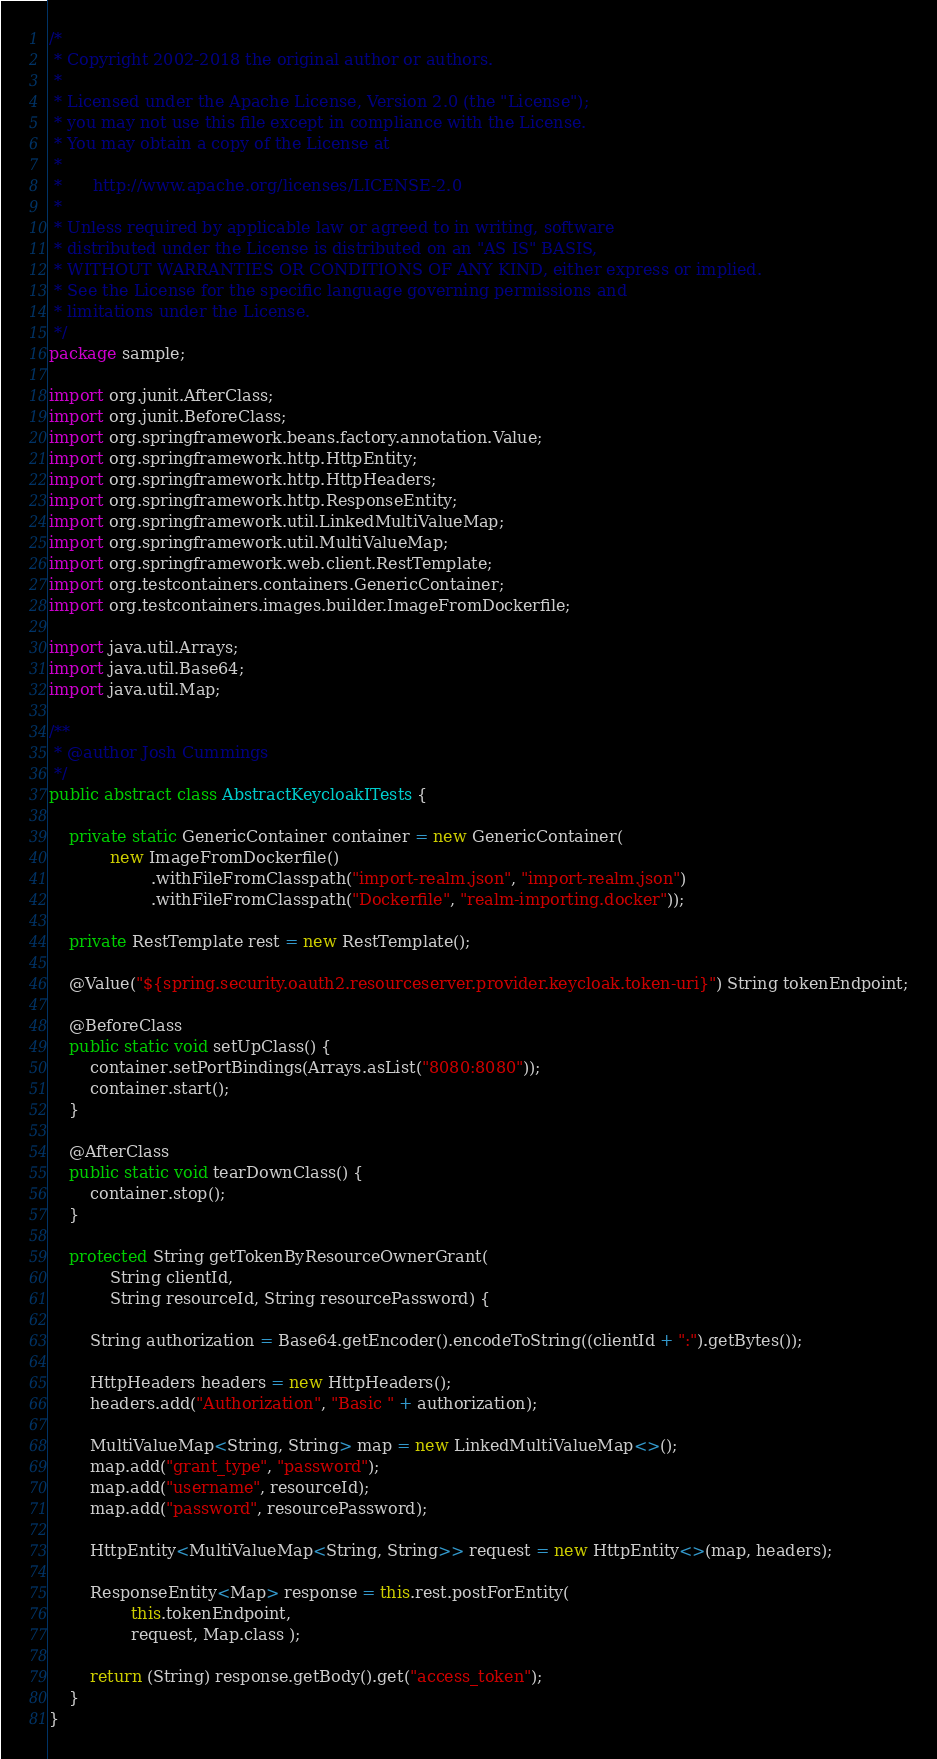Convert code to text. <code><loc_0><loc_0><loc_500><loc_500><_Java_>/*
 * Copyright 2002-2018 the original author or authors.
 *
 * Licensed under the Apache License, Version 2.0 (the "License");
 * you may not use this file except in compliance with the License.
 * You may obtain a copy of the License at
 *
 *      http://www.apache.org/licenses/LICENSE-2.0
 *
 * Unless required by applicable law or agreed to in writing, software
 * distributed under the License is distributed on an "AS IS" BASIS,
 * WITHOUT WARRANTIES OR CONDITIONS OF ANY KIND, either express or implied.
 * See the License for the specific language governing permissions and
 * limitations under the License.
 */
package sample;

import org.junit.AfterClass;
import org.junit.BeforeClass;
import org.springframework.beans.factory.annotation.Value;
import org.springframework.http.HttpEntity;
import org.springframework.http.HttpHeaders;
import org.springframework.http.ResponseEntity;
import org.springframework.util.LinkedMultiValueMap;
import org.springframework.util.MultiValueMap;
import org.springframework.web.client.RestTemplate;
import org.testcontainers.containers.GenericContainer;
import org.testcontainers.images.builder.ImageFromDockerfile;

import java.util.Arrays;
import java.util.Base64;
import java.util.Map;

/**
 * @author Josh Cummings
 */
public abstract class AbstractKeycloakITests {

	private static GenericContainer container = new GenericContainer(
			new ImageFromDockerfile()
					.withFileFromClasspath("import-realm.json", "import-realm.json")
					.withFileFromClasspath("Dockerfile", "realm-importing.docker"));

	private RestTemplate rest = new RestTemplate();

	@Value("${spring.security.oauth2.resourceserver.provider.keycloak.token-uri}") String tokenEndpoint;

	@BeforeClass
	public static void setUpClass() {
		container.setPortBindings(Arrays.asList("8080:8080"));
		container.start();
	}

	@AfterClass
	public static void tearDownClass() {
		container.stop();
	}

	protected String getTokenByResourceOwnerGrant(
			String clientId,
			String resourceId, String resourcePassword) {

		String authorization = Base64.getEncoder().encodeToString((clientId + ":").getBytes());

		HttpHeaders headers = new HttpHeaders();
		headers.add("Authorization", "Basic " + authorization);

		MultiValueMap<String, String> map = new LinkedMultiValueMap<>();
		map.add("grant_type", "password");
		map.add("username", resourceId);
		map.add("password", resourcePassword);

		HttpEntity<MultiValueMap<String, String>> request = new HttpEntity<>(map, headers);

		ResponseEntity<Map> response = this.rest.postForEntity(
				this.tokenEndpoint,
				request, Map.class );

		return (String) response.getBody().get("access_token");
	}
}
</code> 